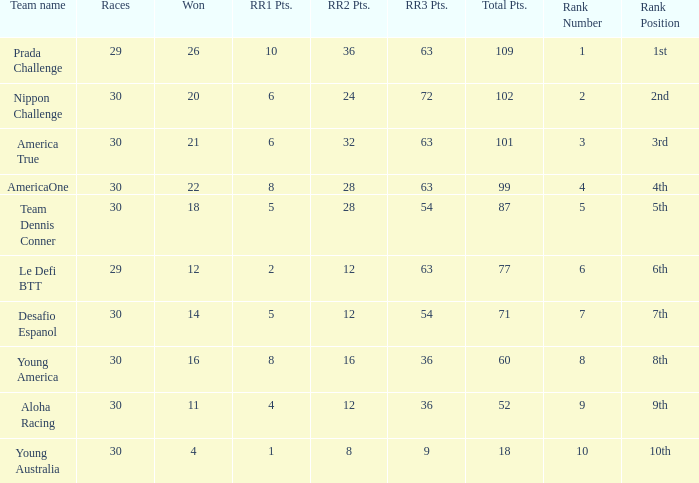Name the most rr1 pts for 7 ranking 5.0. 